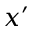<formula> <loc_0><loc_0><loc_500><loc_500>x ^ { \prime }</formula> 